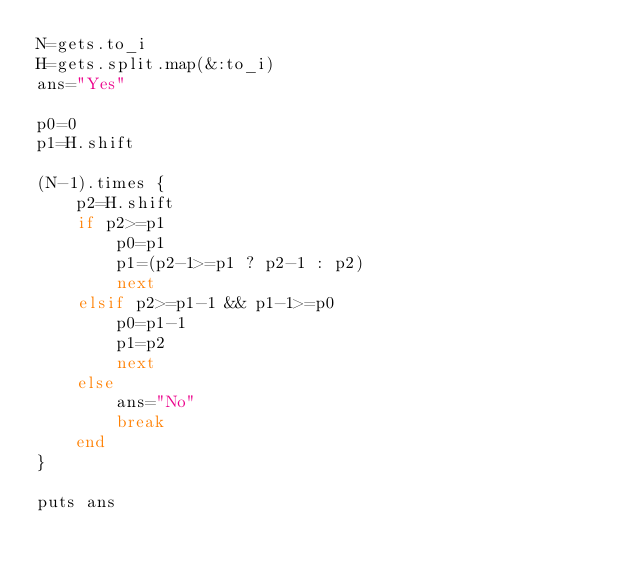Convert code to text. <code><loc_0><loc_0><loc_500><loc_500><_Ruby_>N=gets.to_i
H=gets.split.map(&:to_i)
ans="Yes"

p0=0
p1=H.shift

(N-1).times {
    p2=H.shift
    if p2>=p1
        p0=p1
        p1=(p2-1>=p1 ? p2-1 : p2)
        next
    elsif p2>=p1-1 && p1-1>=p0
        p0=p1-1
        p1=p2
        next
    else
        ans="No"
        break
    end
}

puts ans</code> 